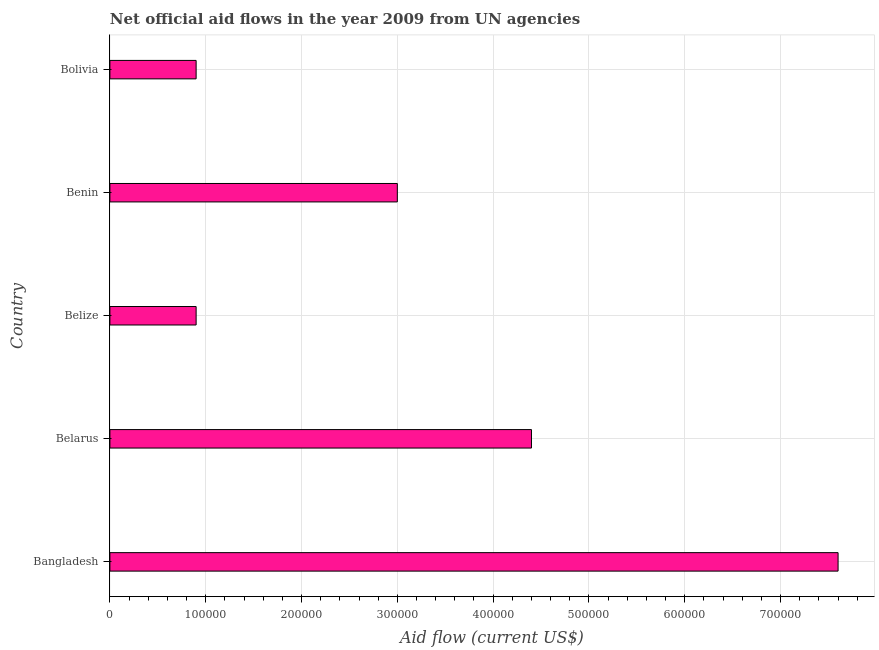Does the graph contain any zero values?
Your response must be concise. No. What is the title of the graph?
Provide a succinct answer. Net official aid flows in the year 2009 from UN agencies. What is the label or title of the Y-axis?
Your response must be concise. Country. Across all countries, what is the maximum net official flows from un agencies?
Give a very brief answer. 7.60e+05. Across all countries, what is the minimum net official flows from un agencies?
Ensure brevity in your answer.  9.00e+04. In which country was the net official flows from un agencies minimum?
Your answer should be very brief. Belize. What is the sum of the net official flows from un agencies?
Keep it short and to the point. 1.68e+06. What is the average net official flows from un agencies per country?
Offer a very short reply. 3.36e+05. What is the ratio of the net official flows from un agencies in Belarus to that in Bolivia?
Your answer should be very brief. 4.89. What is the difference between the highest and the second highest net official flows from un agencies?
Your answer should be compact. 3.20e+05. Is the sum of the net official flows from un agencies in Bangladesh and Belarus greater than the maximum net official flows from un agencies across all countries?
Provide a short and direct response. Yes. What is the difference between the highest and the lowest net official flows from un agencies?
Ensure brevity in your answer.  6.70e+05. How many bars are there?
Your response must be concise. 5. Are all the bars in the graph horizontal?
Your answer should be very brief. Yes. What is the difference between two consecutive major ticks on the X-axis?
Give a very brief answer. 1.00e+05. What is the Aid flow (current US$) of Bangladesh?
Provide a short and direct response. 7.60e+05. What is the Aid flow (current US$) in Bolivia?
Ensure brevity in your answer.  9.00e+04. What is the difference between the Aid flow (current US$) in Bangladesh and Belarus?
Ensure brevity in your answer.  3.20e+05. What is the difference between the Aid flow (current US$) in Bangladesh and Belize?
Offer a terse response. 6.70e+05. What is the difference between the Aid flow (current US$) in Bangladesh and Bolivia?
Keep it short and to the point. 6.70e+05. What is the difference between the Aid flow (current US$) in Belarus and Benin?
Give a very brief answer. 1.40e+05. What is the difference between the Aid flow (current US$) in Belarus and Bolivia?
Offer a very short reply. 3.50e+05. What is the difference between the Aid flow (current US$) in Belize and Benin?
Your answer should be very brief. -2.10e+05. What is the difference between the Aid flow (current US$) in Belize and Bolivia?
Your answer should be very brief. 0. What is the ratio of the Aid flow (current US$) in Bangladesh to that in Belarus?
Make the answer very short. 1.73. What is the ratio of the Aid flow (current US$) in Bangladesh to that in Belize?
Offer a very short reply. 8.44. What is the ratio of the Aid flow (current US$) in Bangladesh to that in Benin?
Provide a succinct answer. 2.53. What is the ratio of the Aid flow (current US$) in Bangladesh to that in Bolivia?
Keep it short and to the point. 8.44. What is the ratio of the Aid flow (current US$) in Belarus to that in Belize?
Make the answer very short. 4.89. What is the ratio of the Aid flow (current US$) in Belarus to that in Benin?
Your answer should be very brief. 1.47. What is the ratio of the Aid flow (current US$) in Belarus to that in Bolivia?
Offer a terse response. 4.89. What is the ratio of the Aid flow (current US$) in Belize to that in Bolivia?
Keep it short and to the point. 1. What is the ratio of the Aid flow (current US$) in Benin to that in Bolivia?
Give a very brief answer. 3.33. 